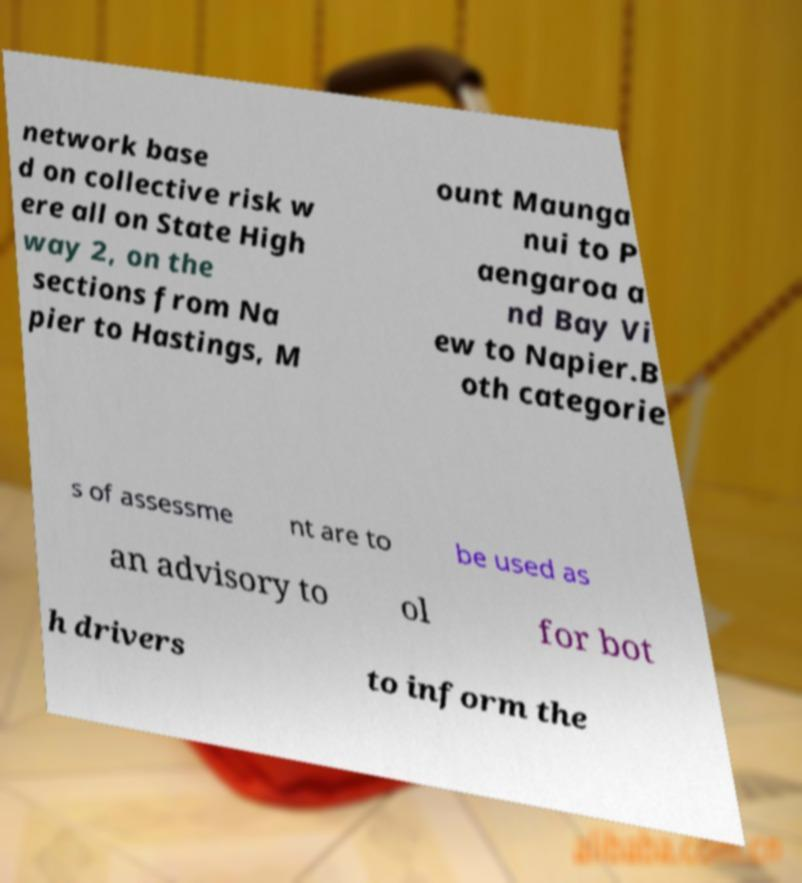Please read and relay the text visible in this image. What does it say? network base d on collective risk w ere all on State High way 2, on the sections from Na pier to Hastings, M ount Maunga nui to P aengaroa a nd Bay Vi ew to Napier.B oth categorie s of assessme nt are to be used as an advisory to ol for bot h drivers to inform the 